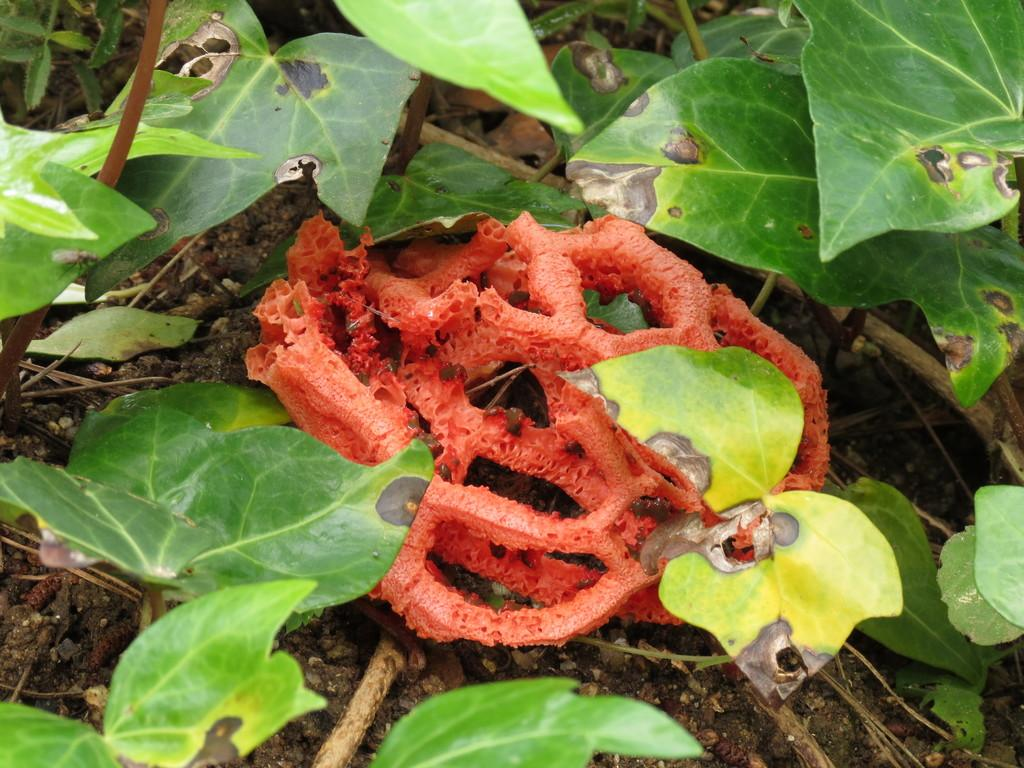What type of organism can be seen in the image? There is a fungus in the image. What other living organisms are present in the image? There are plants in the image. Can you see any bats hanging from the fungus in the image? There are no bats present in the image; it only features a fungus and plants. Is there any cheese visible in the image? There is no cheese present in the image. 